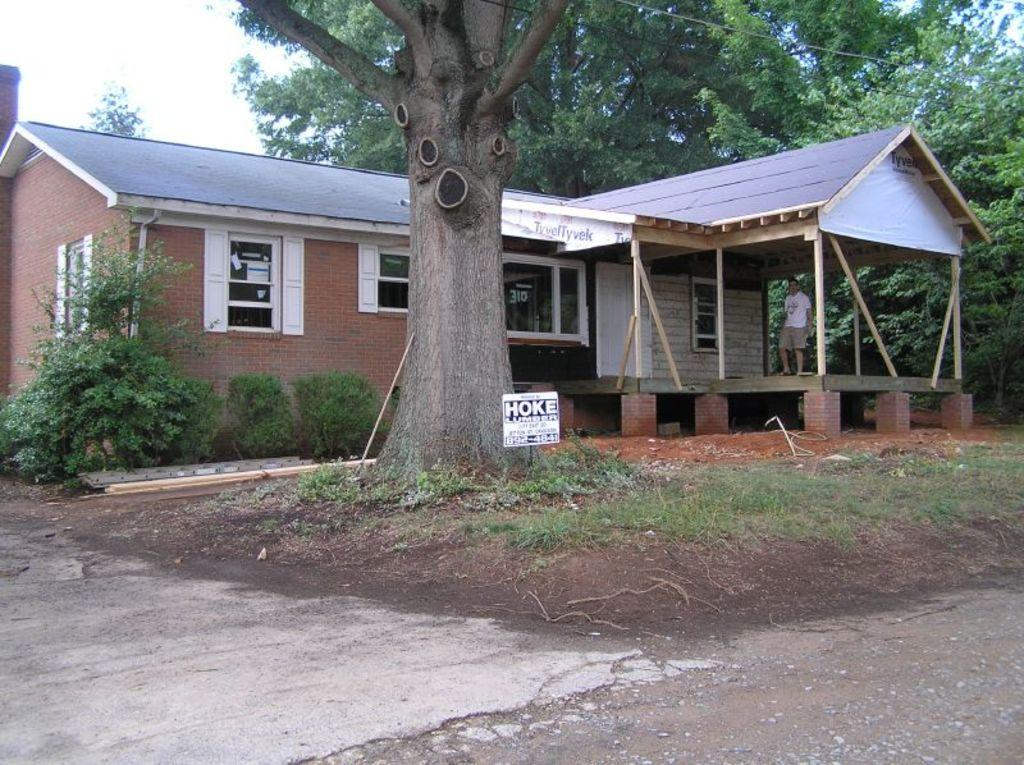What type of structure is visible in the image? There is a house in the image. What are some features of the house? The house has windows and is surrounded by trees. What else can be seen in the image besides the house? Wires and a white color board are present in the image. What is written on the board? Something is written on the board, but we cannot determine the content from the image. How many people are in the image? One person is standing in the image. What is the color of the sky in the image? The sky is visible in the image and appears to be white. How much debt does the person standing in the image have? There is no information about the person's debt in the image, as it does not contain any financial details. 